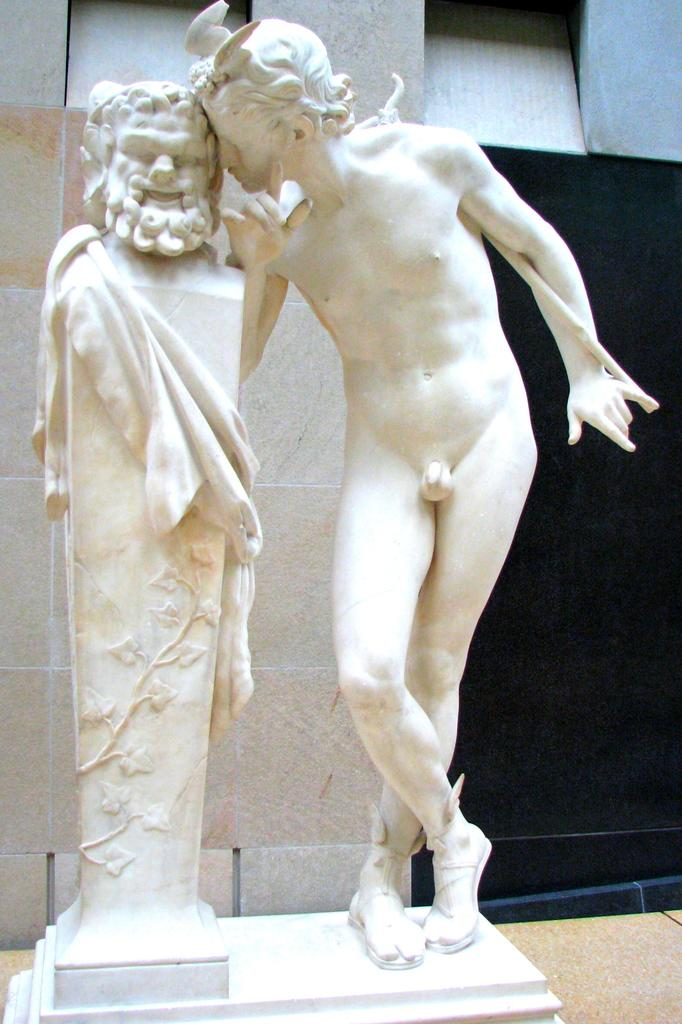What is the main subject in the image? There is a sculpture in the image. Can you describe the background of the image? There is a wall behind the sculpture. What type of rice is being served in the class depicted in the image? There is no class or rice present in the image; it features a sculpture and a wall. 